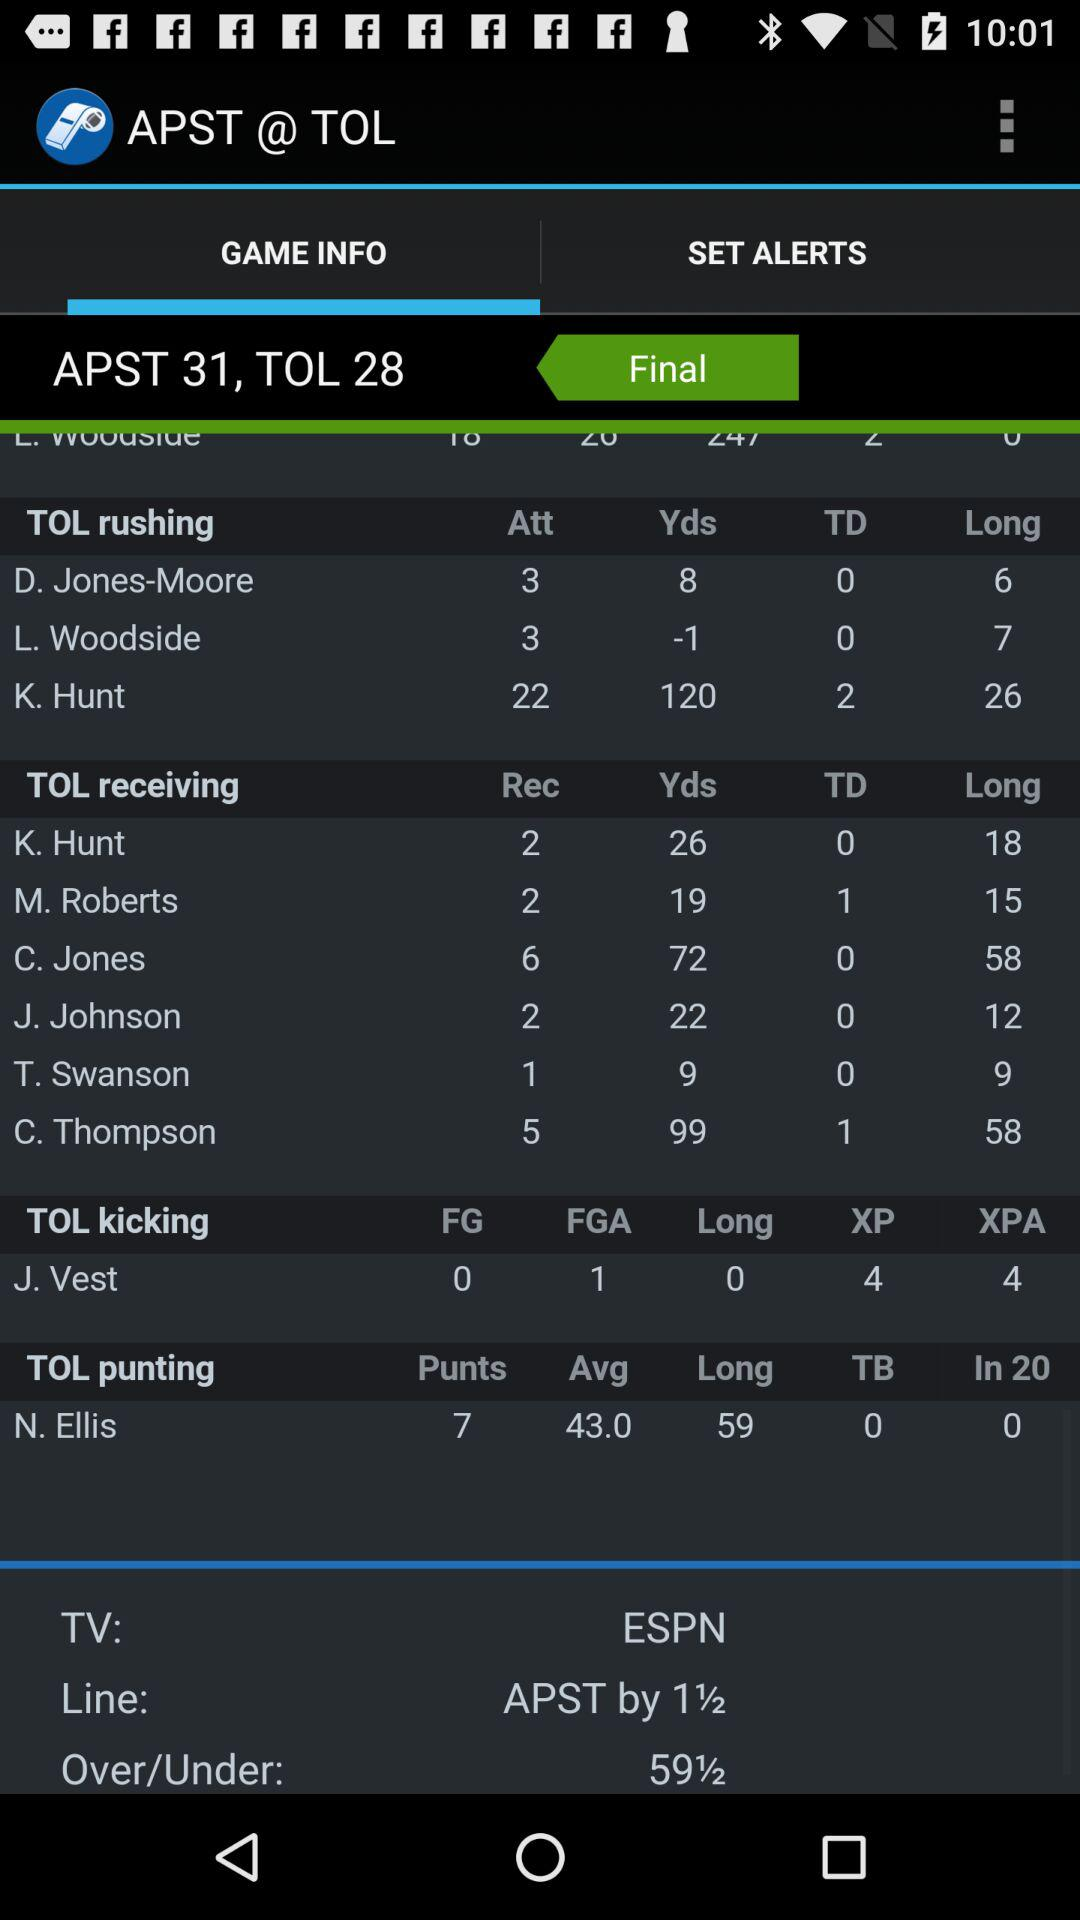What is the overall score? The overall score of the APST is 31 and the TOL is 28. 